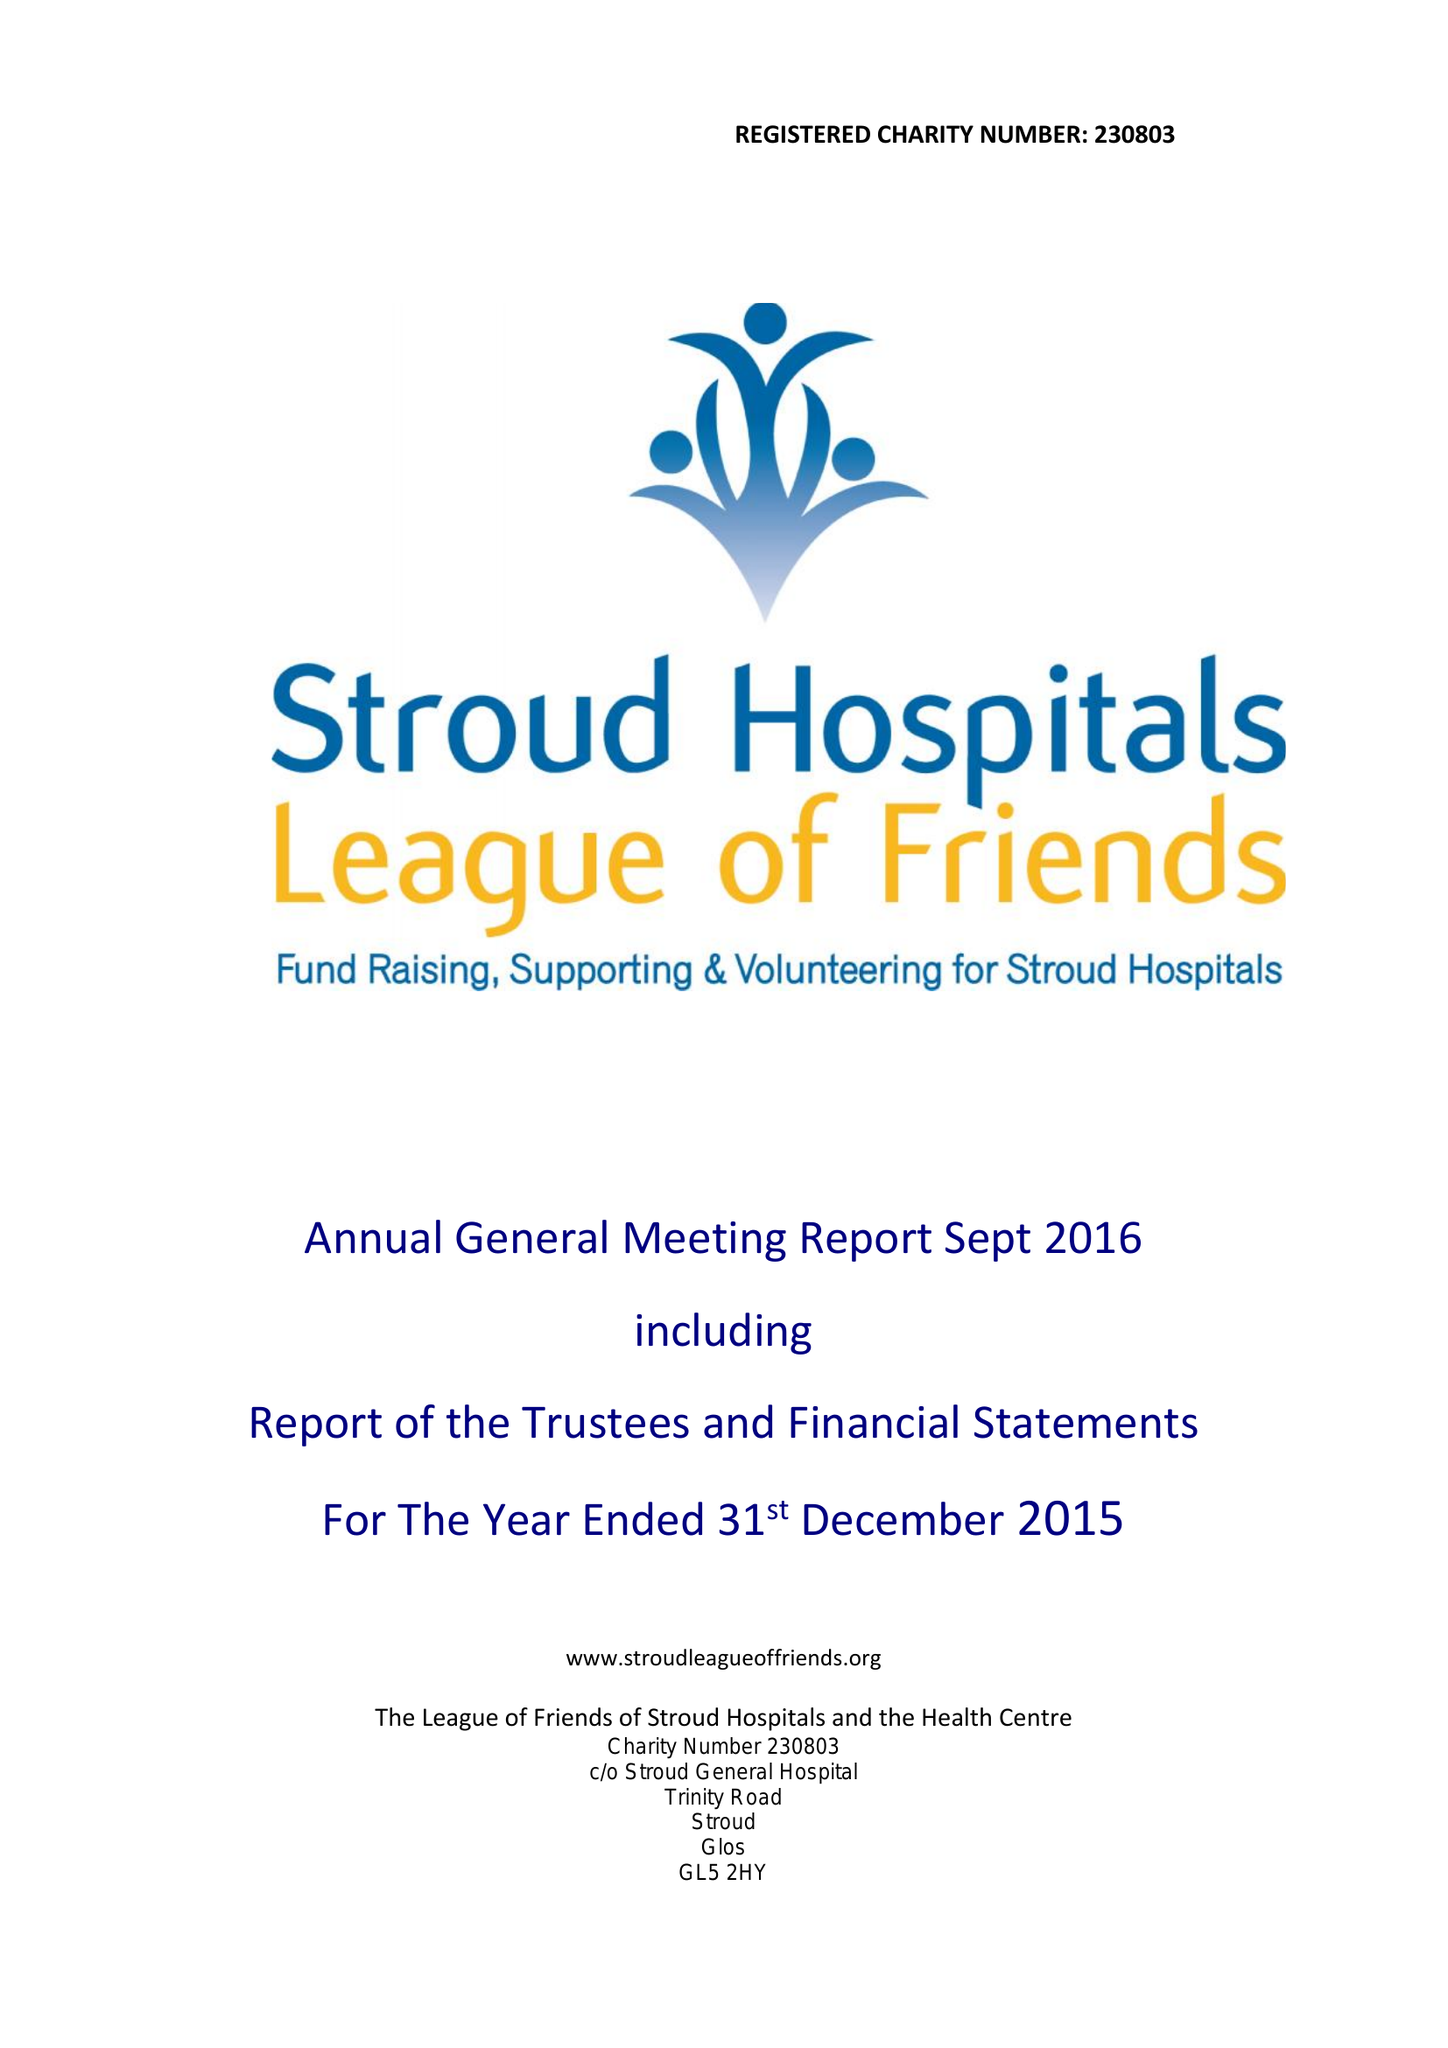What is the value for the address__postcode?
Answer the question using a single word or phrase. GL5 2HY 